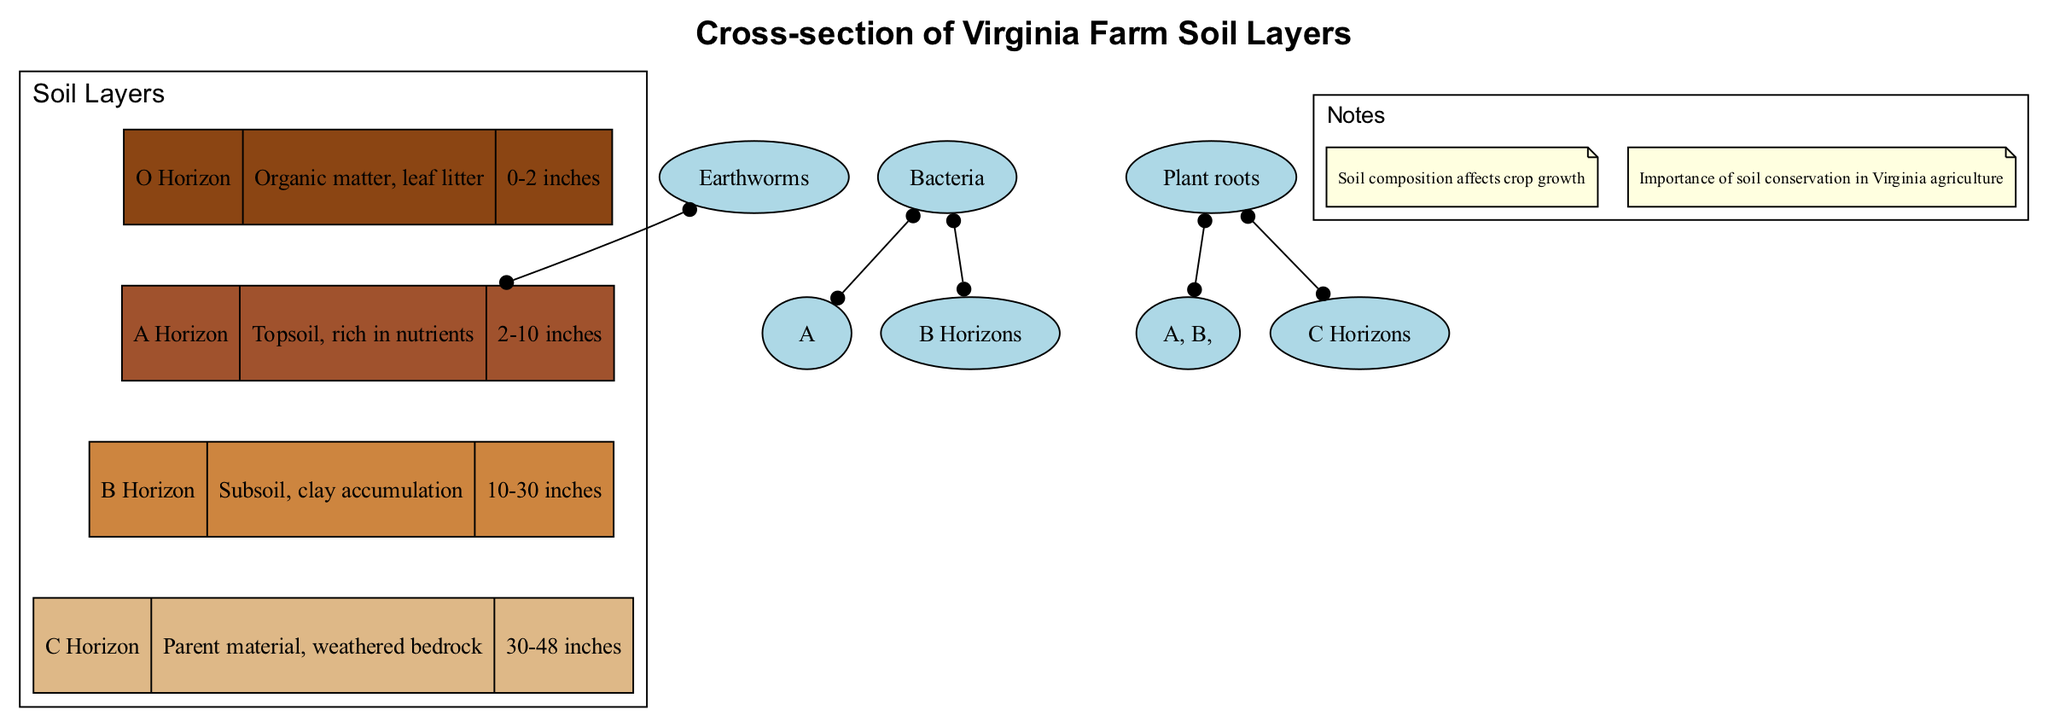What is the depth range of the A Horizon? The A Horizon is described with a depth of "2-10 inches" in the diagram. This depth range indicates where this layer is located within the soil profile.
Answer: 2-10 inches Which layer contains organic matter? The O Horizon is specifically described as containing "Organic matter, leaf litter," making it the relevant layer for this characteristic.
Answer: O Horizon How many organisms are listed in the diagram? The diagram lists a total of three organisms: Earthworms, Bacteria, and Plant roots. Thus, the total count provides the answer.
Answer: 3 Which organisms are found in the A Horizon? The diagram states that Earthworms and Bacteria are found in the A Horizon, according to their specific locations indicated in the diagram.
Answer: Earthworms, Bacteria What is the primary component of the B Horizon? The B Horizon is described as "Subsoil, clay accumulation," which directly tells us the primary component of this layer.
Answer: Clay accumulation Which layer lies directly above the C Horizon? According to the diagram, the layer directly above the C Horizon is the B Horizon, based on the vertical arrangement of the layers.
Answer: B Horizon What is the significance of soil composition according to the notes? The notes highlight that "Soil composition affects crop growth," indicating its importance for agricultural practices.
Answer: Affects crop growth In which horizons can plant roots be found? The diagram indicates that Plant roots are found in the A, B, and C Horizons as noted under the organisms section.
Answer: A, B, and C Horizons What is the color associated with the O Horizon? The color associated with the O Horizon, as per the diagram's color coding, is identified as SaddleBrown, which is typically used in representations of this soil layer.
Answer: SaddleBrown 